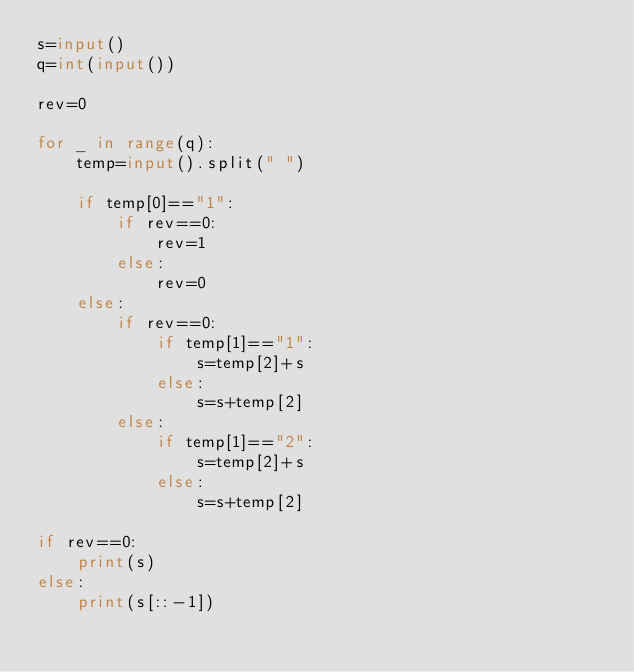<code> <loc_0><loc_0><loc_500><loc_500><_Python_>s=input()
q=int(input())

rev=0

for _ in range(q):
    temp=input().split(" ")
    
    if temp[0]=="1":
        if rev==0:
            rev=1
        else:
            rev=0
    else:
        if rev==0:
            if temp[1]=="1":
                s=temp[2]+s
            else:
                s=s+temp[2]
        else:
            if temp[1]=="2":
                s=temp[2]+s
            else:
                s=s+temp[2]

if rev==0:
    print(s)
else:
    print(s[::-1])</code> 